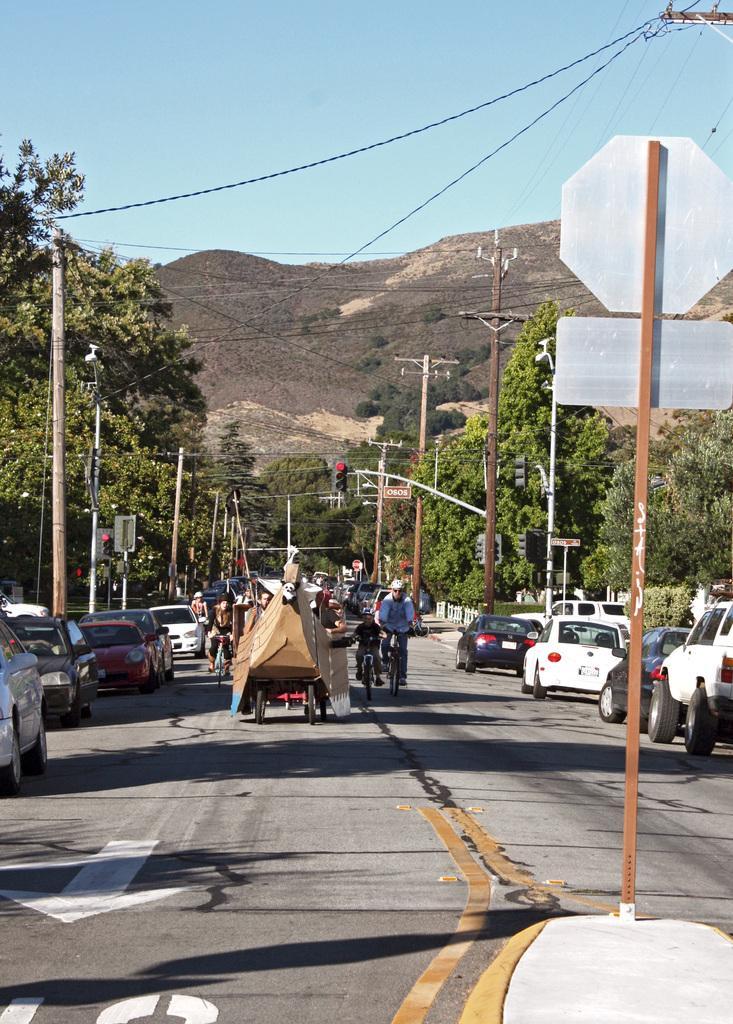How would you summarize this image in a sentence or two? In this image I can see few vehicles on the road. I can see few people are riding a bicycle. I can see few signboards,poles,current poles,wires,trees,traffic-signal and mountains. The sky is in blue and white color. 